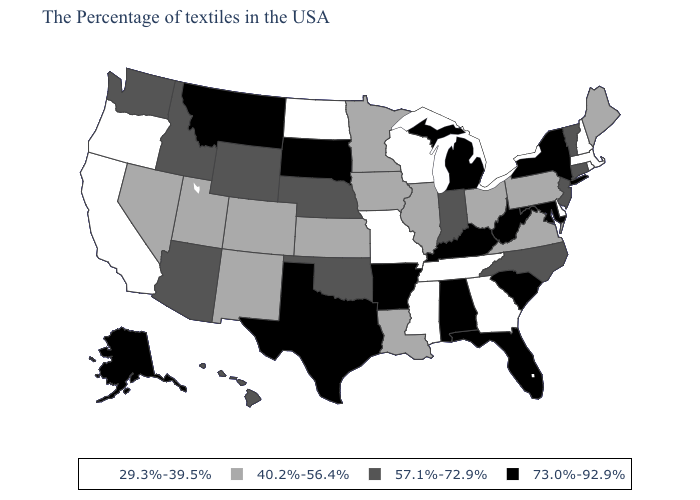Among the states that border Vermont , which have the lowest value?
Quick response, please. Massachusetts, New Hampshire. Which states have the highest value in the USA?
Write a very short answer. New York, Maryland, South Carolina, West Virginia, Florida, Michigan, Kentucky, Alabama, Arkansas, Texas, South Dakota, Montana, Alaska. Name the states that have a value in the range 57.1%-72.9%?
Short answer required. Vermont, Connecticut, New Jersey, North Carolina, Indiana, Nebraska, Oklahoma, Wyoming, Arizona, Idaho, Washington, Hawaii. What is the value of Kentucky?
Quick response, please. 73.0%-92.9%. What is the lowest value in the West?
Answer briefly. 29.3%-39.5%. Which states have the lowest value in the USA?
Short answer required. Massachusetts, Rhode Island, New Hampshire, Delaware, Georgia, Tennessee, Wisconsin, Mississippi, Missouri, North Dakota, California, Oregon. Name the states that have a value in the range 73.0%-92.9%?
Give a very brief answer. New York, Maryland, South Carolina, West Virginia, Florida, Michigan, Kentucky, Alabama, Arkansas, Texas, South Dakota, Montana, Alaska. What is the lowest value in the MidWest?
Be succinct. 29.3%-39.5%. Name the states that have a value in the range 40.2%-56.4%?
Write a very short answer. Maine, Pennsylvania, Virginia, Ohio, Illinois, Louisiana, Minnesota, Iowa, Kansas, Colorado, New Mexico, Utah, Nevada. Which states have the lowest value in the Northeast?
Short answer required. Massachusetts, Rhode Island, New Hampshire. What is the value of North Dakota?
Write a very short answer. 29.3%-39.5%. Name the states that have a value in the range 73.0%-92.9%?
Be succinct. New York, Maryland, South Carolina, West Virginia, Florida, Michigan, Kentucky, Alabama, Arkansas, Texas, South Dakota, Montana, Alaska. What is the highest value in the MidWest ?
Answer briefly. 73.0%-92.9%. What is the highest value in the USA?
Answer briefly. 73.0%-92.9%. Which states have the lowest value in the South?
Concise answer only. Delaware, Georgia, Tennessee, Mississippi. 